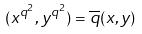Convert formula to latex. <formula><loc_0><loc_0><loc_500><loc_500>( x ^ { q ^ { 2 } } , y ^ { q ^ { 2 } } ) = \overline { q } ( x , y )</formula> 